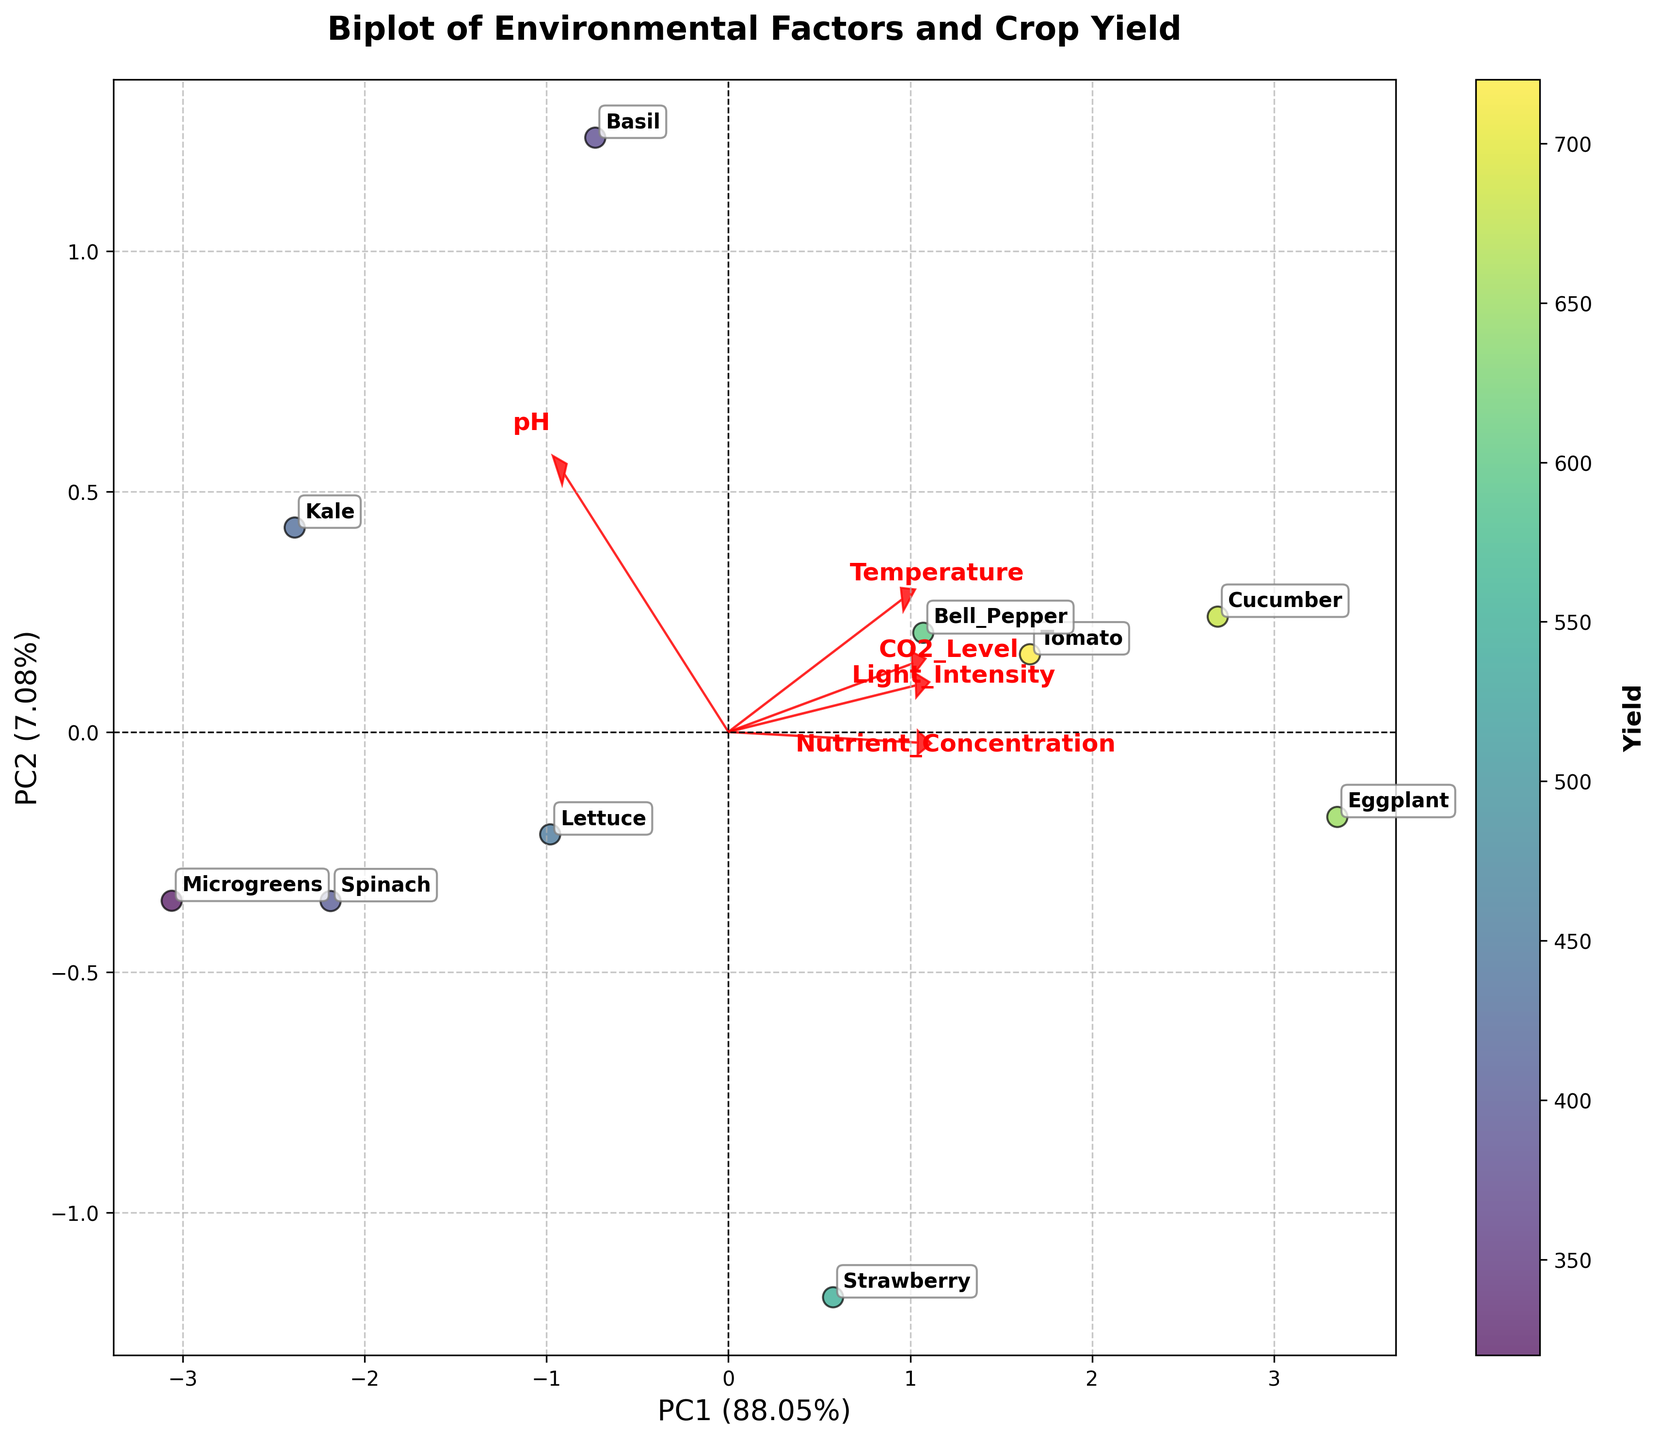What are the axes labeled as? The horizontal axis is labeled "PC1" and represents the first principal component, explaining the highest variance (percentage indicated in the axis label). The vertical axis is labeled "PC2" and represents the second principal component.
Answer: PC1 and PC2 What color represents higher yield? The biplot uses a color gradient to represent yield, from lighter to darker shades. The darker shades indicate higher yield, as evidenced by the "Yield" label beside the color bar.
Answer: Darker shades Which crop appears closest to the origin (0,0) of the plot? The crop that appears closest to the origin is "Spinach," as its position on the biplot is near the central axes where PC1 and PC2 intersect.
Answer: Spinach Considering Light Intensity and Temperature, which factor has a greater influence in the first principal component (PC1)? The loadings for Light Intensity and Temperature are shown as red arrows. Light Intensity's arrow is longer and stretches further along PC1 than Temperature's arrow, indicating a stronger influence on PC1.
Answer: Light Intensity Which environmental factor appears to be most strongly associated with a high yield? The color gradient helps in identifying high yield regions. Crops with high yield show darker colors. The red arrows (loadings) for Nutrient Concentration and CO2 Level, pointing towards those crops, indicate a strong association with a high yield.
Answer: Nutrient Concentration and CO2 Level Which crops have a yield closest to 450? The color bar shows yellow as the approximate yield range near 450. Crops shown in yellow shades close to the middle yield range include "Bell Pepper" and "Lettuce."
Answer: Bell Pepper and Lettuce Which environmental factor is least influential on both PC1 and PC2? The environmental factor with the shortest red arrow is "pH," indicating it has the least influence on both PC1 and PC2 as compared to the other factors.
Answer: pH How much variance is explained by PC1 and PC2 collectively? The variance explained by PC1 and PC2 is shown on their respective axes. PC1 explains 56% of the variance, and PC2 explains 26%. Summing these gives the total variance explained by both components.
Answer: 82% Between Tomato and Cucumber, which crop has a higher yield? By observing the color gradient and the crops' coloring, "Cucumber" is in a darker shade relative to "Tomato," indicating a higher yield.
Answer: Cucumber What are the coordinates of the "Bell Pepper" on the biplot with respect to PC1 and PC2? "Bell Pepper" is positioned a bit to the right of the vertical axis and slightly above the horizontal axis. The coordinates approximate to those positions, most likely near (0.5, 0.2).
Answer: (0.5, 0.2) 